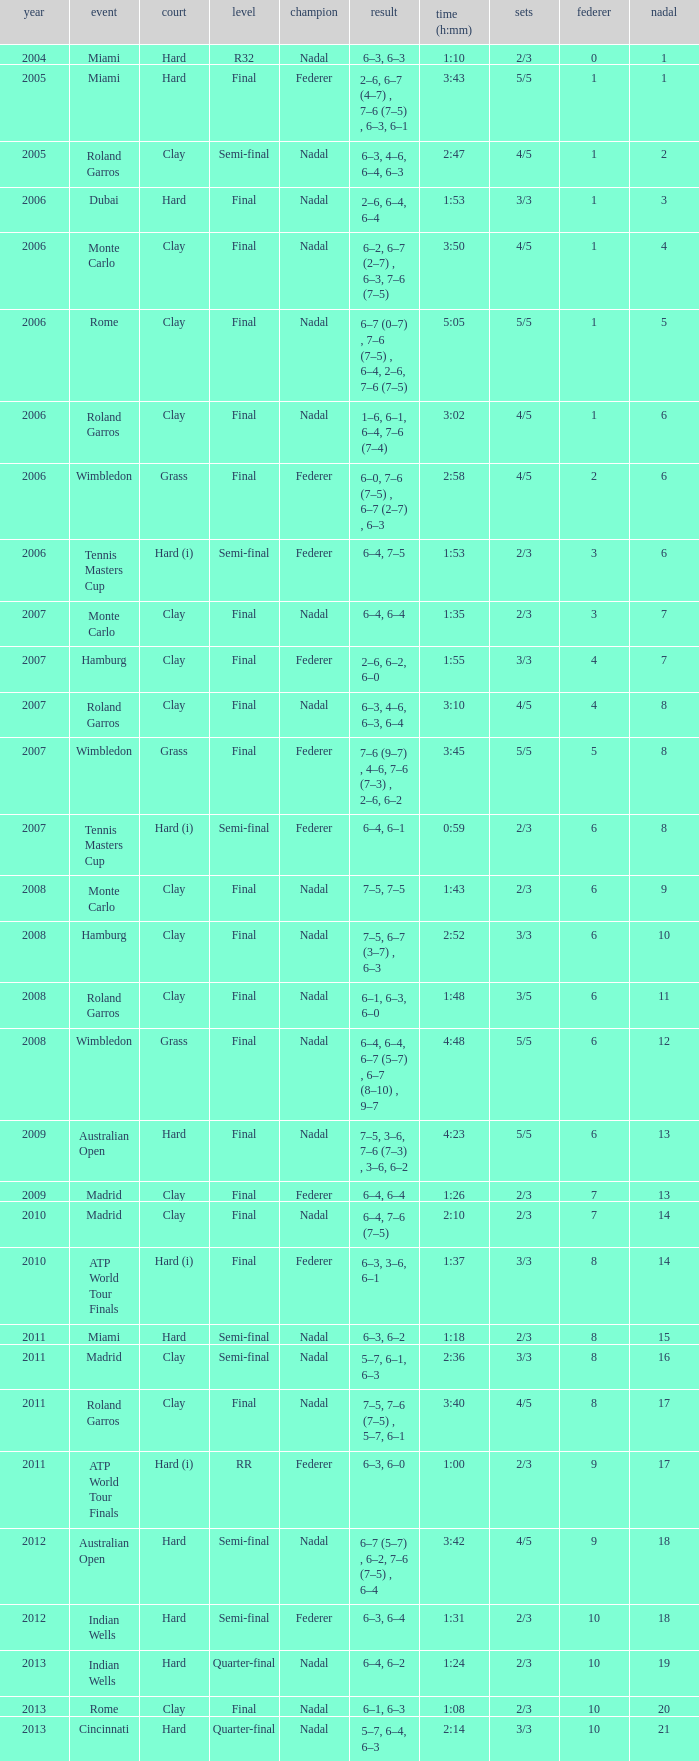What were the sets when Federer had 6 and a nadal of 13? 5/5. Help me parse the entirety of this table. {'header': ['year', 'event', 'court', 'level', 'champion', 'result', 'time (h:mm)', 'sets', 'federer', 'nadal'], 'rows': [['2004', 'Miami', 'Hard', 'R32', 'Nadal', '6–3, 6–3', '1:10', '2/3', '0', '1'], ['2005', 'Miami', 'Hard', 'Final', 'Federer', '2–6, 6–7 (4–7) , 7–6 (7–5) , 6–3, 6–1', '3:43', '5/5', '1', '1'], ['2005', 'Roland Garros', 'Clay', 'Semi-final', 'Nadal', '6–3, 4–6, 6–4, 6–3', '2:47', '4/5', '1', '2'], ['2006', 'Dubai', 'Hard', 'Final', 'Nadal', '2–6, 6–4, 6–4', '1:53', '3/3', '1', '3'], ['2006', 'Monte Carlo', 'Clay', 'Final', 'Nadal', '6–2, 6–7 (2–7) , 6–3, 7–6 (7–5)', '3:50', '4/5', '1', '4'], ['2006', 'Rome', 'Clay', 'Final', 'Nadal', '6–7 (0–7) , 7–6 (7–5) , 6–4, 2–6, 7–6 (7–5)', '5:05', '5/5', '1', '5'], ['2006', 'Roland Garros', 'Clay', 'Final', 'Nadal', '1–6, 6–1, 6–4, 7–6 (7–4)', '3:02', '4/5', '1', '6'], ['2006', 'Wimbledon', 'Grass', 'Final', 'Federer', '6–0, 7–6 (7–5) , 6–7 (2–7) , 6–3', '2:58', '4/5', '2', '6'], ['2006', 'Tennis Masters Cup', 'Hard (i)', 'Semi-final', 'Federer', '6–4, 7–5', '1:53', '2/3', '3', '6'], ['2007', 'Monte Carlo', 'Clay', 'Final', 'Nadal', '6–4, 6–4', '1:35', '2/3', '3', '7'], ['2007', 'Hamburg', 'Clay', 'Final', 'Federer', '2–6, 6–2, 6–0', '1:55', '3/3', '4', '7'], ['2007', 'Roland Garros', 'Clay', 'Final', 'Nadal', '6–3, 4–6, 6–3, 6–4', '3:10', '4/5', '4', '8'], ['2007', 'Wimbledon', 'Grass', 'Final', 'Federer', '7–6 (9–7) , 4–6, 7–6 (7–3) , 2–6, 6–2', '3:45', '5/5', '5', '8'], ['2007', 'Tennis Masters Cup', 'Hard (i)', 'Semi-final', 'Federer', '6–4, 6–1', '0:59', '2/3', '6', '8'], ['2008', 'Monte Carlo', 'Clay', 'Final', 'Nadal', '7–5, 7–5', '1:43', '2/3', '6', '9'], ['2008', 'Hamburg', 'Clay', 'Final', 'Nadal', '7–5, 6–7 (3–7) , 6–3', '2:52', '3/3', '6', '10'], ['2008', 'Roland Garros', 'Clay', 'Final', 'Nadal', '6–1, 6–3, 6–0', '1:48', '3/5', '6', '11'], ['2008', 'Wimbledon', 'Grass', 'Final', 'Nadal', '6–4, 6–4, 6–7 (5–7) , 6–7 (8–10) , 9–7', '4:48', '5/5', '6', '12'], ['2009', 'Australian Open', 'Hard', 'Final', 'Nadal', '7–5, 3–6, 7–6 (7–3) , 3–6, 6–2', '4:23', '5/5', '6', '13'], ['2009', 'Madrid', 'Clay', 'Final', 'Federer', '6–4, 6–4', '1:26', '2/3', '7', '13'], ['2010', 'Madrid', 'Clay', 'Final', 'Nadal', '6–4, 7–6 (7–5)', '2:10', '2/3', '7', '14'], ['2010', 'ATP World Tour Finals', 'Hard (i)', 'Final', 'Federer', '6–3, 3–6, 6–1', '1:37', '3/3', '8', '14'], ['2011', 'Miami', 'Hard', 'Semi-final', 'Nadal', '6–3, 6–2', '1:18', '2/3', '8', '15'], ['2011', 'Madrid', 'Clay', 'Semi-final', 'Nadal', '5–7, 6–1, 6–3', '2:36', '3/3', '8', '16'], ['2011', 'Roland Garros', 'Clay', 'Final', 'Nadal', '7–5, 7–6 (7–5) , 5–7, 6–1', '3:40', '4/5', '8', '17'], ['2011', 'ATP World Tour Finals', 'Hard (i)', 'RR', 'Federer', '6–3, 6–0', '1:00', '2/3', '9', '17'], ['2012', 'Australian Open', 'Hard', 'Semi-final', 'Nadal', '6–7 (5–7) , 6–2, 7–6 (7–5) , 6–4', '3:42', '4/5', '9', '18'], ['2012', 'Indian Wells', 'Hard', 'Semi-final', 'Federer', '6–3, 6–4', '1:31', '2/3', '10', '18'], ['2013', 'Indian Wells', 'Hard', 'Quarter-final', 'Nadal', '6–4, 6–2', '1:24', '2/3', '10', '19'], ['2013', 'Rome', 'Clay', 'Final', 'Nadal', '6–1, 6–3', '1:08', '2/3', '10', '20'], ['2013', 'Cincinnati', 'Hard', 'Quarter-final', 'Nadal', '5–7, 6–4, 6–3', '2:14', '3/3', '10', '21']]} 